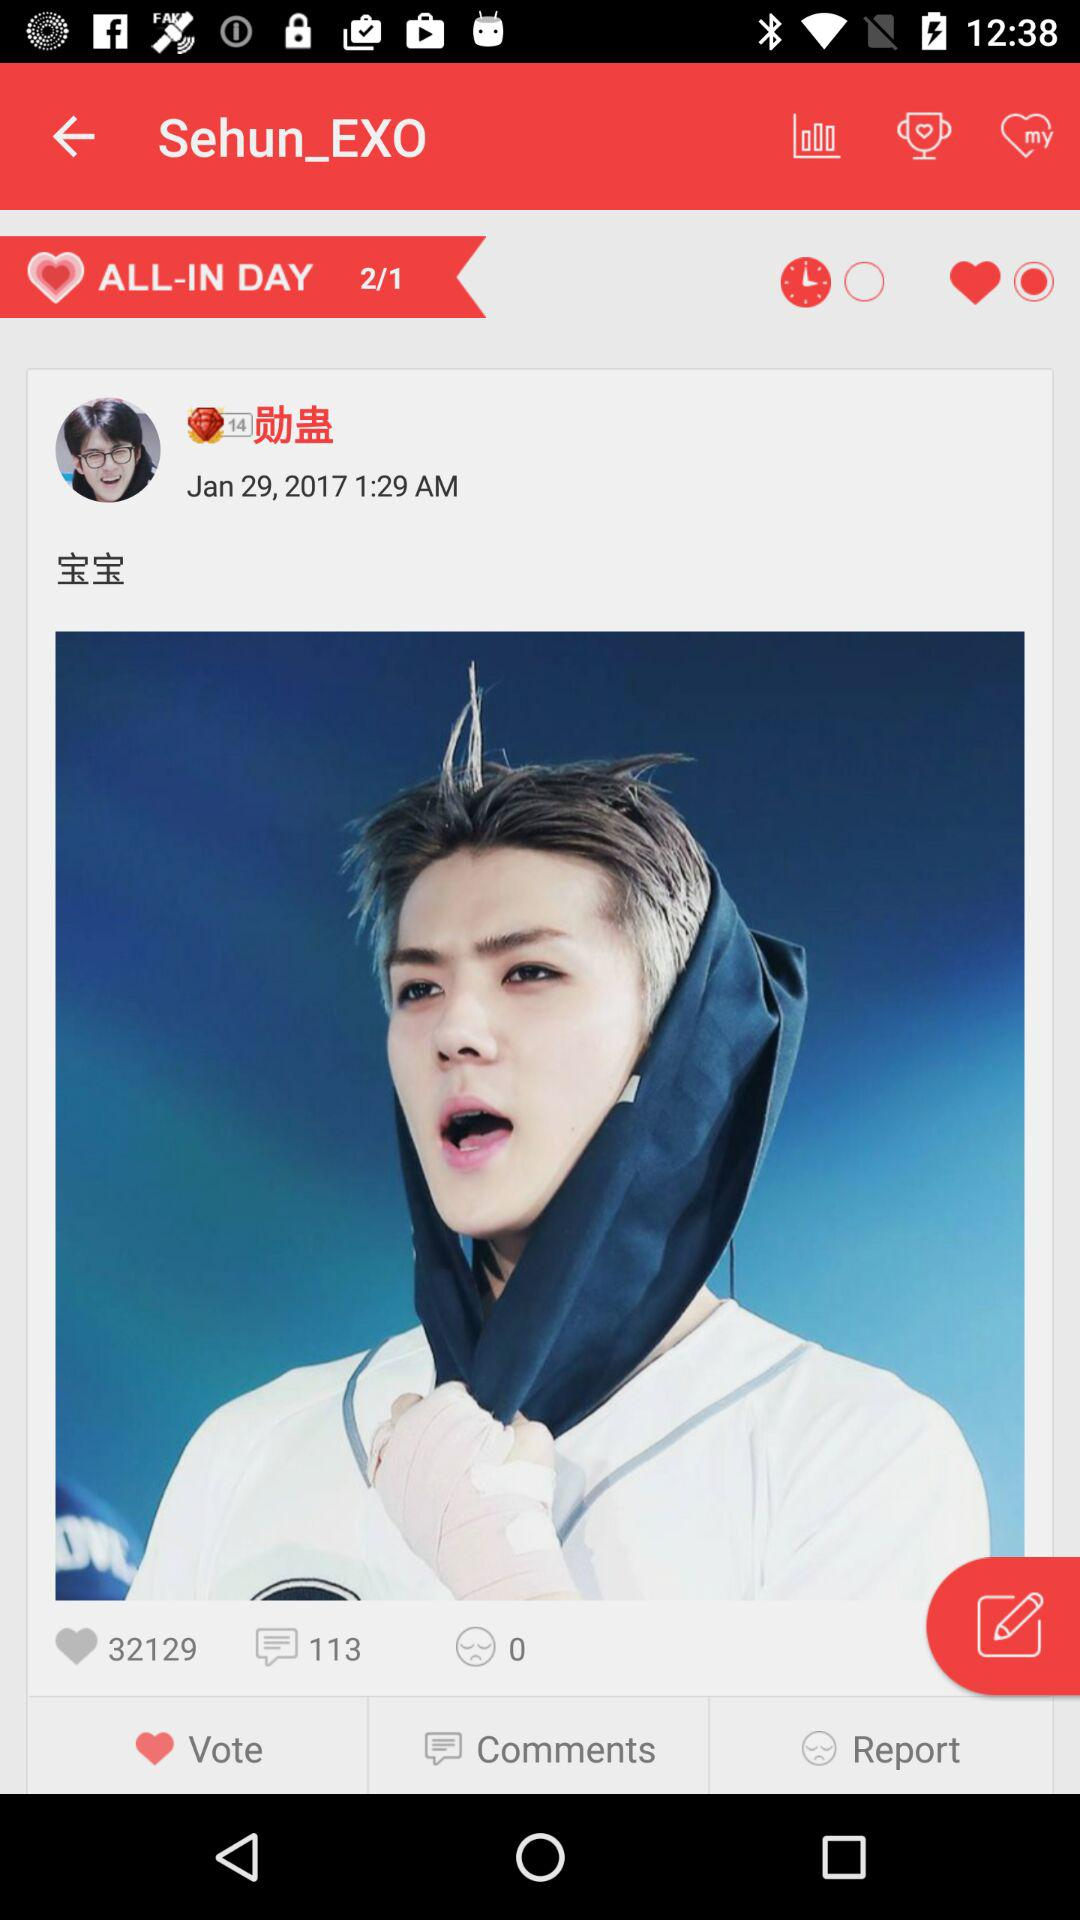How many comments are there? There are 113 comments. 